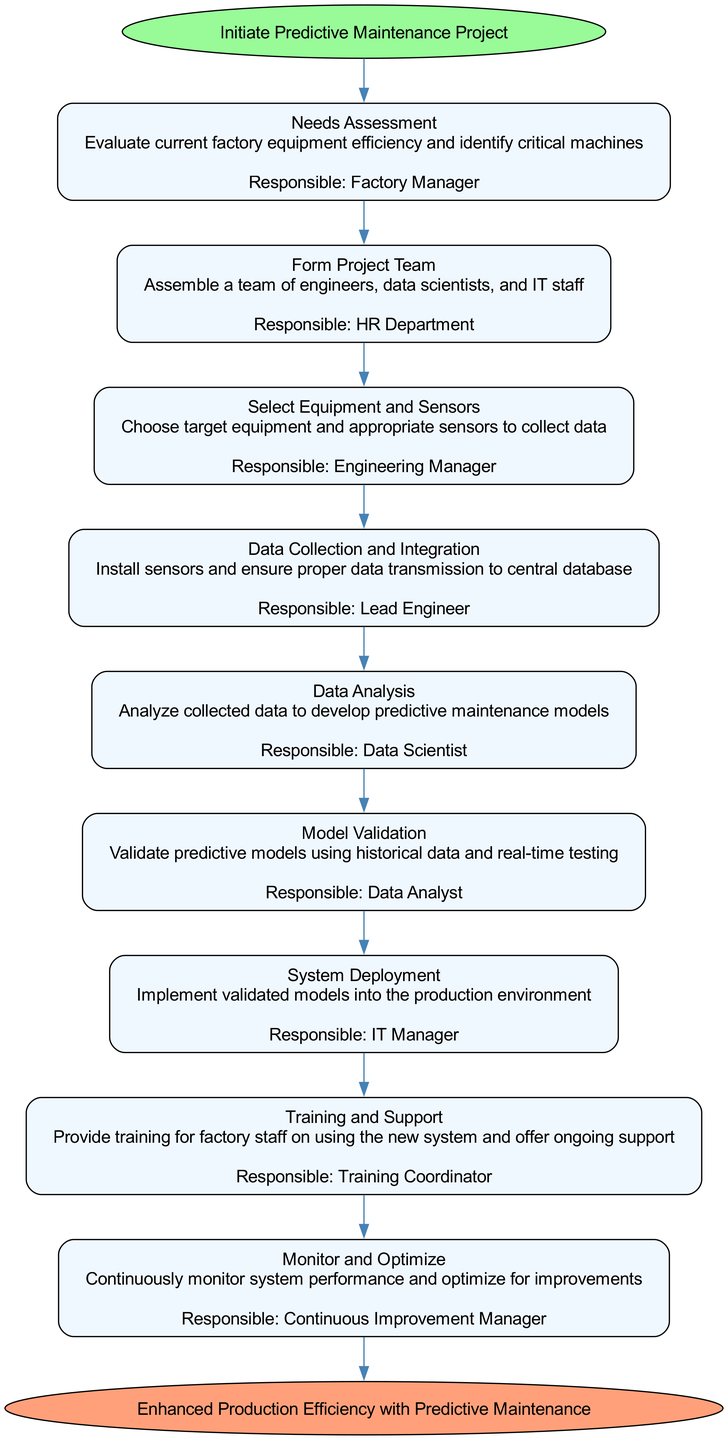What is the first step in the implementation process? The first step listed in the flow chart is "Needs Assessment," which involves evaluating current factory equipment efficiency and identifying critical machines.
Answer: Needs Assessment Who is responsible for "Data Collection and Integration"? According to the flow chart, the "Lead Engineer" is the responsible person for the "Data Collection and Integration" step.
Answer: Lead Engineer How many steps are there in total? The flow chart includes a total of 9 steps, starting from "Needs Assessment" and ending with "Monitor and Optimize," before culminating with the "End" node.
Answer: 9 Which step comes immediately after "Model Validation"? The step that follows "Model Validation" in the sequence is "System Deployment," which involves implementing the validated models into the production environment.
Answer: System Deployment What is the final outcome described in the flow chart? The flow chart concludes with the "End" node indicating the final outcome as "Enhanced Production Efficiency with Predictive Maintenance."
Answer: Enhanced Production Efficiency with Predictive Maintenance Which department forms the project team? The HR Department is responsible for forming the project team as noted in the "Form Project Team" step of the flow chart.
Answer: HR Department How does the "Start" node connect to the next step? The "Start" node connects directly to the "Needs Assessment" step, indicating the initiation of the process.
Answer: Directly connected What is the role of the Continuous Improvement Manager? The Continuous Improvement Manager is responsible for the "Monitor and Optimize" step, where they continuously monitor system performance and work on optimization.
Answer: Monitor and Optimize What action is described in the "Training and Support" step? The "Training and Support" step describes providing training for factory staff on using the new system and offering ongoing support.
Answer: Provide training and ongoing support 